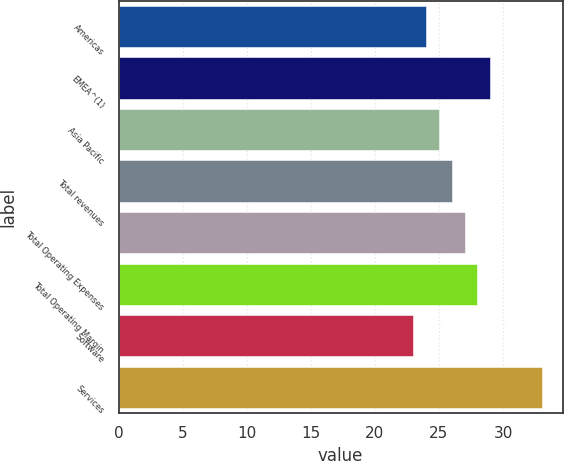Convert chart. <chart><loc_0><loc_0><loc_500><loc_500><bar_chart><fcel>Americas<fcel>EMEA^(1)<fcel>Asia Pacific<fcel>Total revenues<fcel>Total Operating Expenses<fcel>Total Operating Margin<fcel>Software<fcel>Services<nl><fcel>24<fcel>29<fcel>25<fcel>26<fcel>27<fcel>28<fcel>23<fcel>33<nl></chart> 